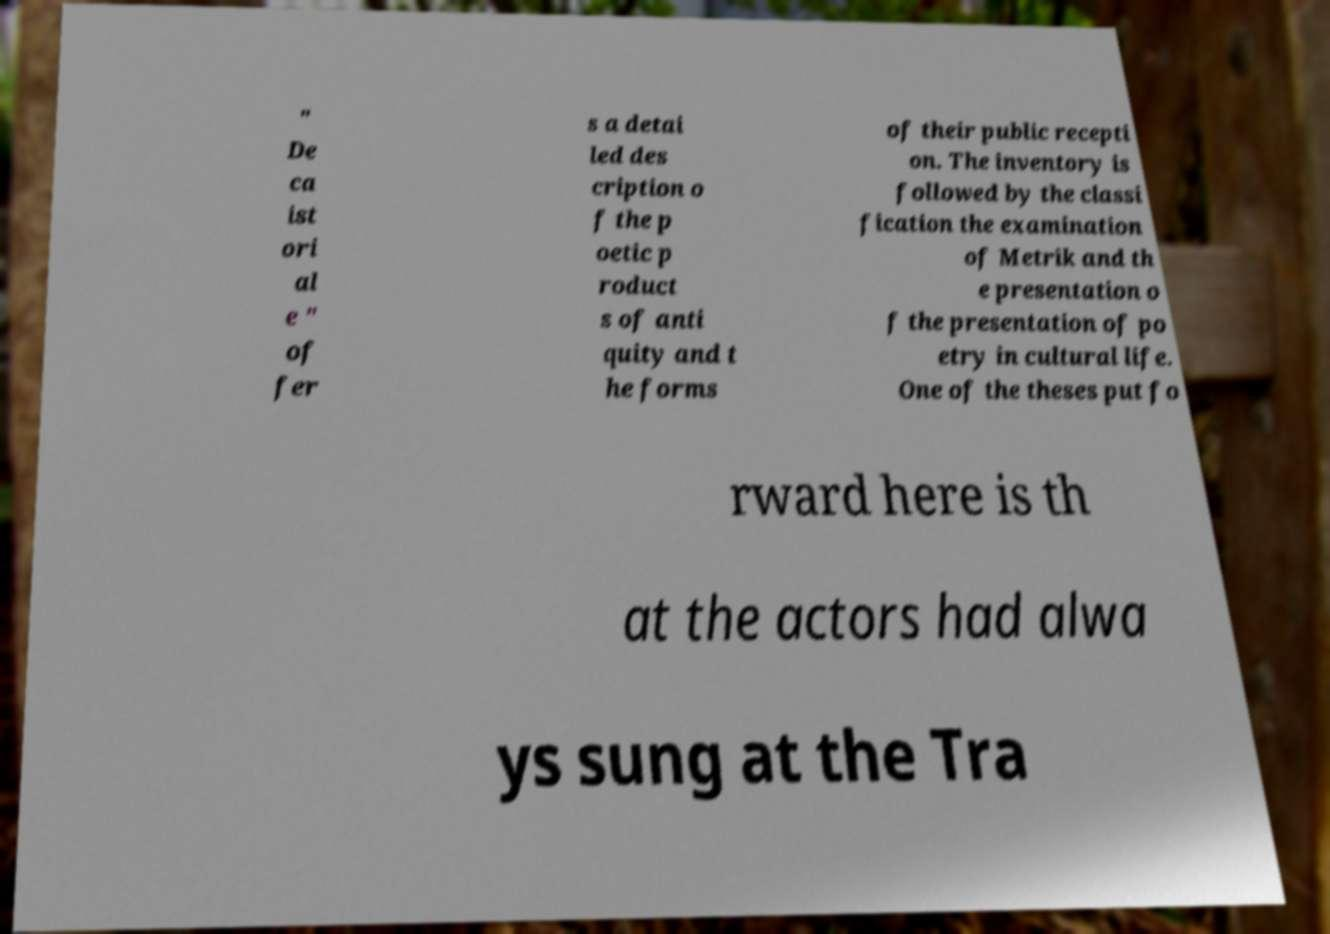Please identify and transcribe the text found in this image. " De ca ist ori al e " of fer s a detai led des cription o f the p oetic p roduct s of anti quity and t he forms of their public recepti on. The inventory is followed by the classi fication the examination of Metrik and th e presentation o f the presentation of po etry in cultural life. One of the theses put fo rward here is th at the actors had alwa ys sung at the Tra 